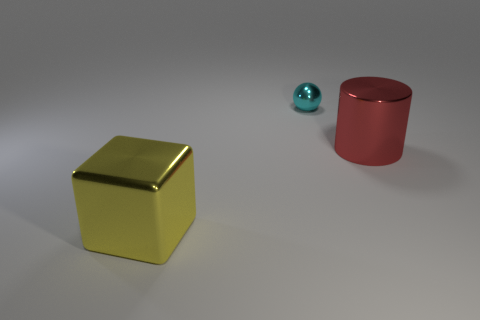Add 2 cyan shiny things. How many objects exist? 5 Subtract all green spheres. Subtract all red cubes. How many spheres are left? 1 Subtract all tiny brown metal cylinders. Subtract all yellow metal blocks. How many objects are left? 2 Add 2 blocks. How many blocks are left? 3 Add 1 big yellow objects. How many big yellow objects exist? 2 Subtract 0 blue cylinders. How many objects are left? 3 Subtract all spheres. How many objects are left? 2 